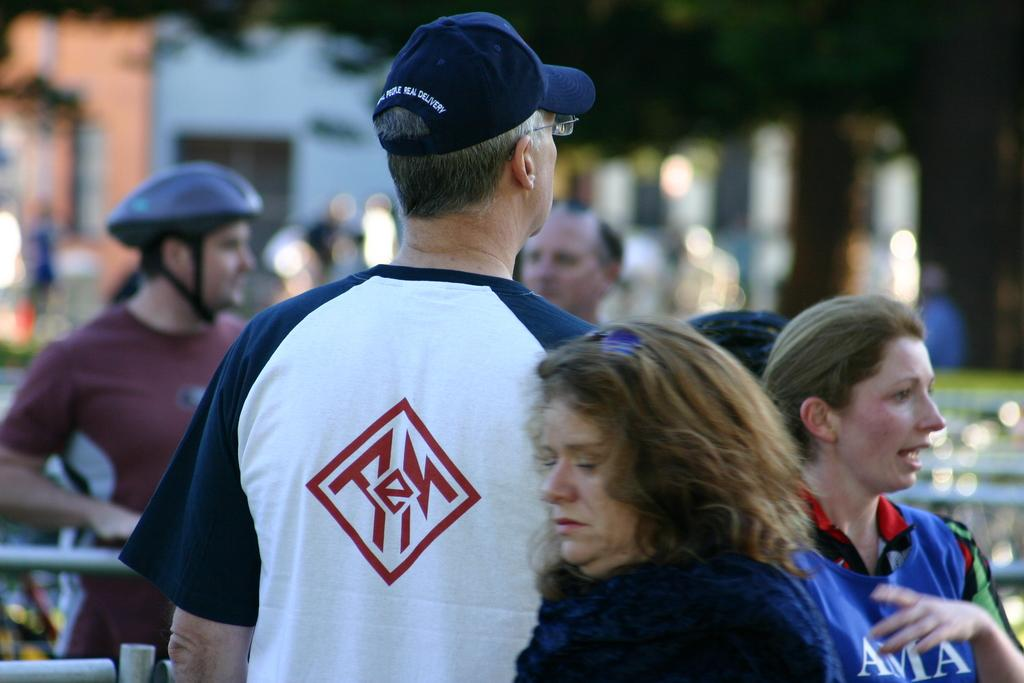<image>
Provide a brief description of the given image. A man in a blue baseball hat wears a shirt with an "E" on the back. 